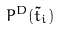<formula> <loc_0><loc_0><loc_500><loc_500>P ^ { D } ( \tilde { t } _ { i } )</formula> 